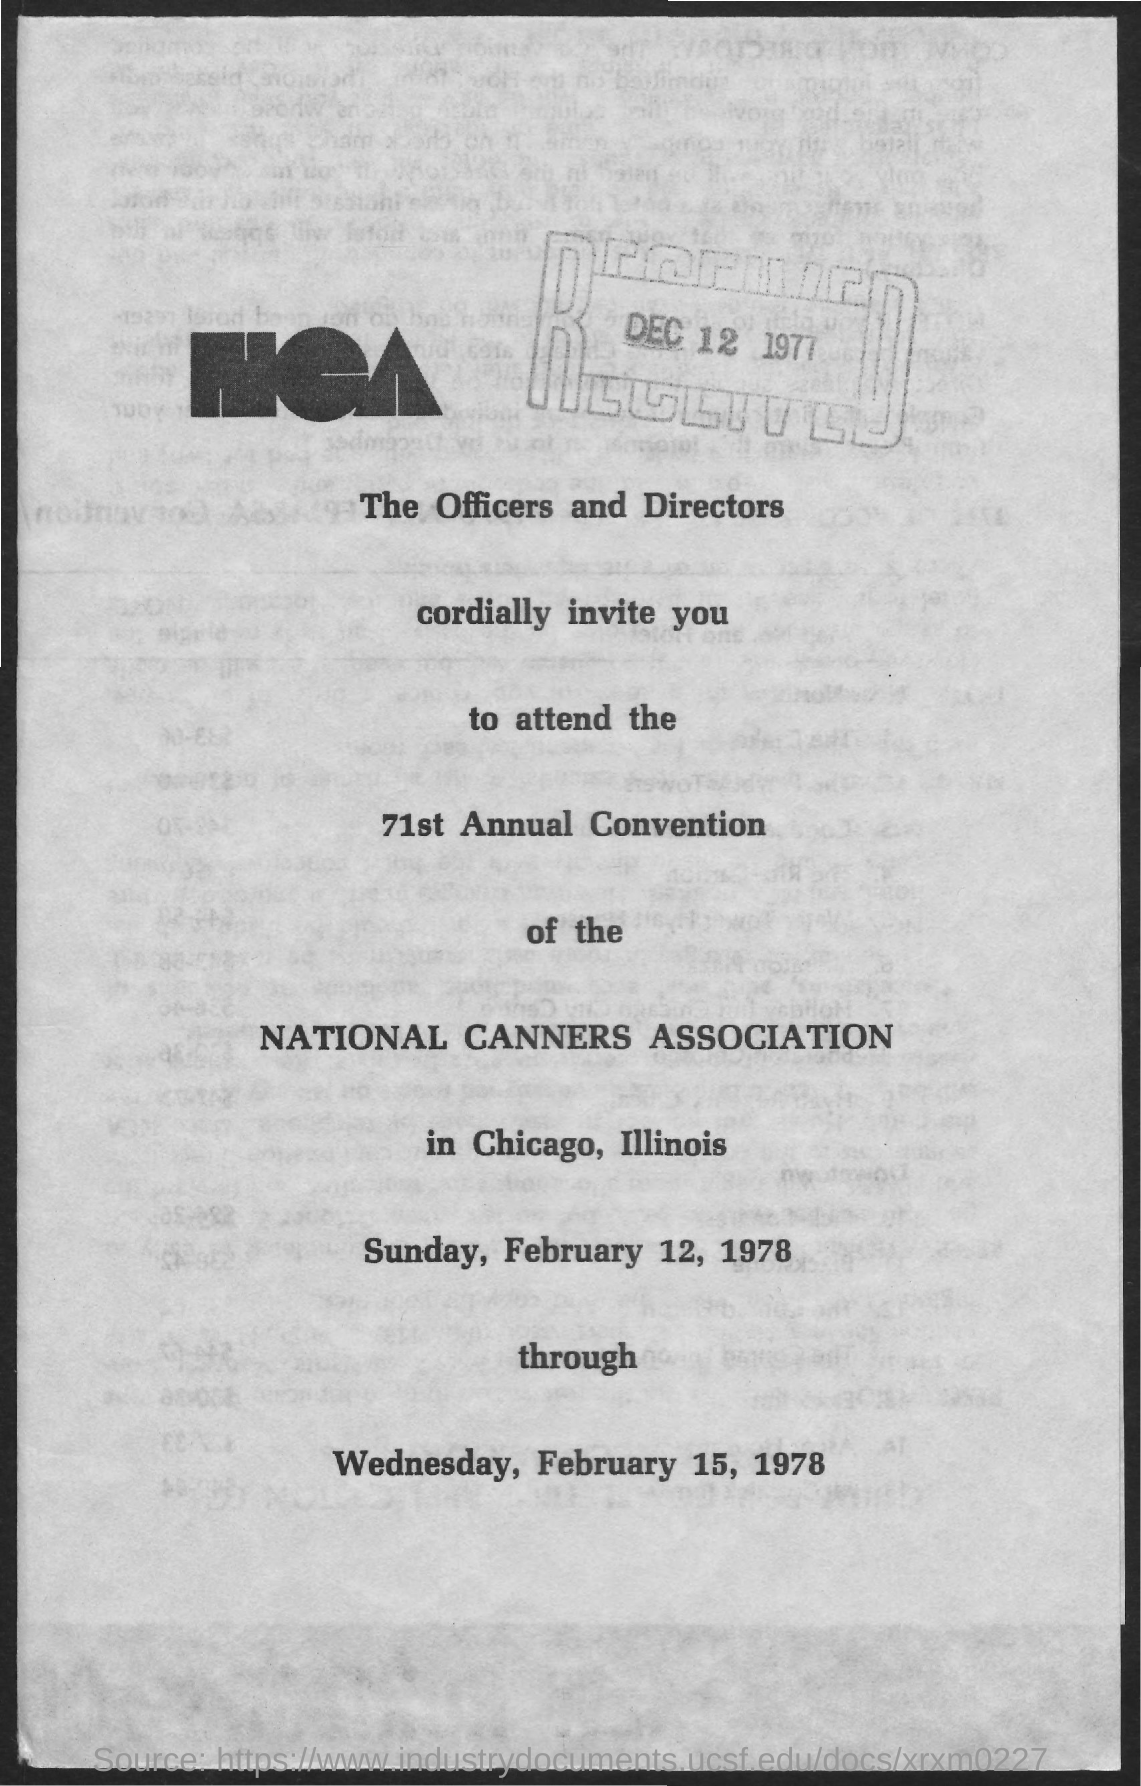When was the document received?
Your response must be concise. DEC 12 1977. Whose Annual convention is mentioned?
Offer a terse response. NATIONAL CANNERS ASSOCIATION. When is the annual convention?
Provide a succinct answer. WEDNESDAY, FEBRUARY 15, 1978. Where is the convention going to be held?
Offer a terse response. Chicago, Illinois. 